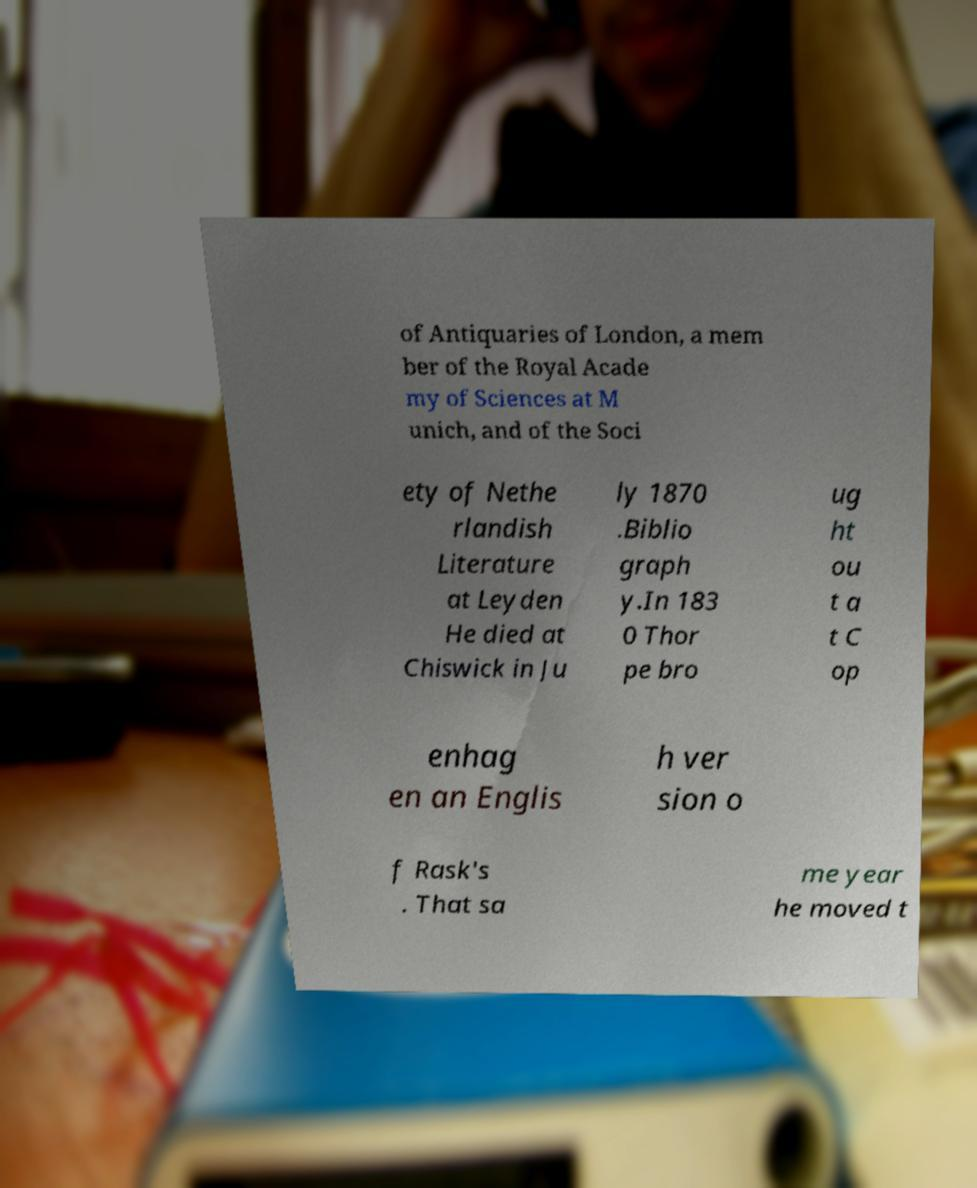For documentation purposes, I need the text within this image transcribed. Could you provide that? of Antiquaries of London, a mem ber of the Royal Acade my of Sciences at M unich, and of the Soci ety of Nethe rlandish Literature at Leyden He died at Chiswick in Ju ly 1870 .Biblio graph y.In 183 0 Thor pe bro ug ht ou t a t C op enhag en an Englis h ver sion o f Rask's . That sa me year he moved t 